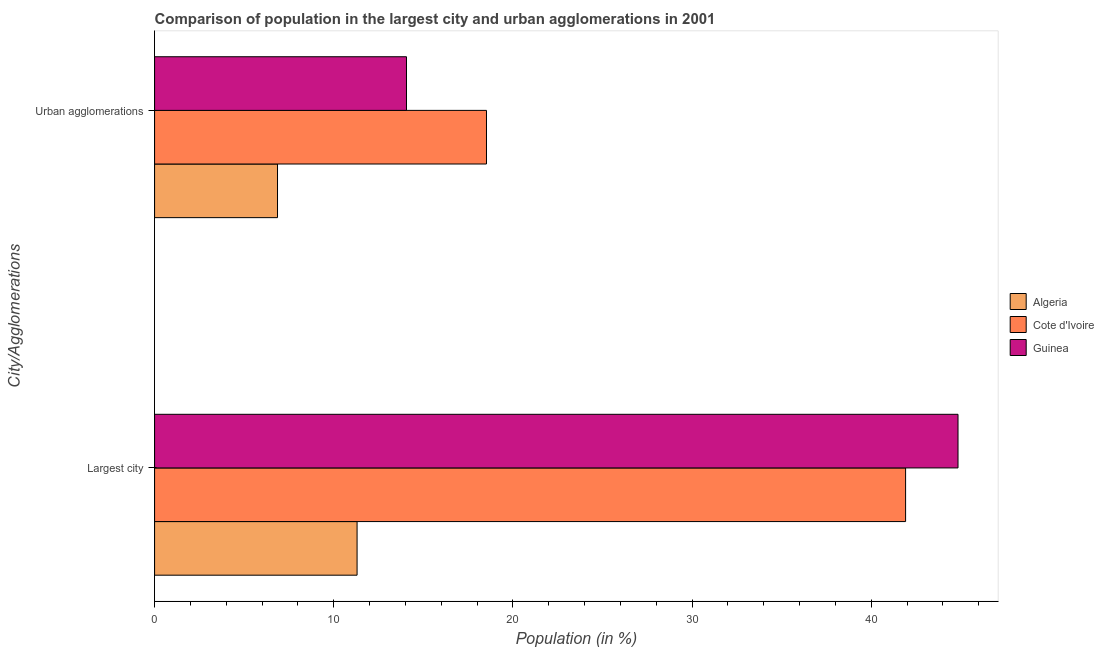Are the number of bars per tick equal to the number of legend labels?
Make the answer very short. Yes. How many bars are there on the 1st tick from the bottom?
Provide a short and direct response. 3. What is the label of the 2nd group of bars from the top?
Your response must be concise. Largest city. What is the population in urban agglomerations in Cote d'Ivoire?
Give a very brief answer. 18.53. Across all countries, what is the maximum population in urban agglomerations?
Make the answer very short. 18.53. Across all countries, what is the minimum population in the largest city?
Your response must be concise. 11.3. In which country was the population in the largest city maximum?
Offer a terse response. Guinea. In which country was the population in the largest city minimum?
Provide a succinct answer. Algeria. What is the total population in the largest city in the graph?
Offer a terse response. 98.07. What is the difference between the population in urban agglomerations in Algeria and that in Cote d'Ivoire?
Make the answer very short. -11.66. What is the difference between the population in the largest city in Algeria and the population in urban agglomerations in Guinea?
Ensure brevity in your answer.  -2.76. What is the average population in the largest city per country?
Ensure brevity in your answer.  32.69. What is the difference between the population in the largest city and population in urban agglomerations in Cote d'Ivoire?
Your response must be concise. 23.39. In how many countries, is the population in urban agglomerations greater than 44 %?
Make the answer very short. 0. What is the ratio of the population in urban agglomerations in Guinea to that in Cote d'Ivoire?
Give a very brief answer. 0.76. Is the population in urban agglomerations in Algeria less than that in Guinea?
Make the answer very short. Yes. In how many countries, is the population in the largest city greater than the average population in the largest city taken over all countries?
Keep it short and to the point. 2. What does the 2nd bar from the top in Largest city represents?
Ensure brevity in your answer.  Cote d'Ivoire. What does the 3rd bar from the bottom in Urban agglomerations represents?
Give a very brief answer. Guinea. How many bars are there?
Give a very brief answer. 6. Are all the bars in the graph horizontal?
Your answer should be compact. Yes. How many countries are there in the graph?
Your answer should be very brief. 3. Are the values on the major ticks of X-axis written in scientific E-notation?
Your answer should be compact. No. Does the graph contain grids?
Give a very brief answer. No. How many legend labels are there?
Ensure brevity in your answer.  3. How are the legend labels stacked?
Provide a succinct answer. Vertical. What is the title of the graph?
Offer a very short reply. Comparison of population in the largest city and urban agglomerations in 2001. What is the label or title of the Y-axis?
Provide a short and direct response. City/Agglomerations. What is the Population (in %) in Algeria in Largest city?
Ensure brevity in your answer.  11.3. What is the Population (in %) of Cote d'Ivoire in Largest city?
Provide a short and direct response. 41.92. What is the Population (in %) of Guinea in Largest city?
Provide a short and direct response. 44.85. What is the Population (in %) in Algeria in Urban agglomerations?
Provide a succinct answer. 6.86. What is the Population (in %) of Cote d'Ivoire in Urban agglomerations?
Provide a short and direct response. 18.53. What is the Population (in %) in Guinea in Urban agglomerations?
Your response must be concise. 14.06. Across all City/Agglomerations, what is the maximum Population (in %) in Algeria?
Offer a very short reply. 11.3. Across all City/Agglomerations, what is the maximum Population (in %) in Cote d'Ivoire?
Offer a terse response. 41.92. Across all City/Agglomerations, what is the maximum Population (in %) of Guinea?
Give a very brief answer. 44.85. Across all City/Agglomerations, what is the minimum Population (in %) in Algeria?
Your response must be concise. 6.86. Across all City/Agglomerations, what is the minimum Population (in %) of Cote d'Ivoire?
Make the answer very short. 18.53. Across all City/Agglomerations, what is the minimum Population (in %) of Guinea?
Offer a terse response. 14.06. What is the total Population (in %) in Algeria in the graph?
Make the answer very short. 18.17. What is the total Population (in %) of Cote d'Ivoire in the graph?
Make the answer very short. 60.45. What is the total Population (in %) in Guinea in the graph?
Offer a terse response. 58.91. What is the difference between the Population (in %) in Algeria in Largest city and that in Urban agglomerations?
Your answer should be compact. 4.44. What is the difference between the Population (in %) in Cote d'Ivoire in Largest city and that in Urban agglomerations?
Offer a terse response. 23.39. What is the difference between the Population (in %) in Guinea in Largest city and that in Urban agglomerations?
Offer a terse response. 30.79. What is the difference between the Population (in %) in Algeria in Largest city and the Population (in %) in Cote d'Ivoire in Urban agglomerations?
Keep it short and to the point. -7.22. What is the difference between the Population (in %) in Algeria in Largest city and the Population (in %) in Guinea in Urban agglomerations?
Provide a short and direct response. -2.76. What is the difference between the Population (in %) of Cote d'Ivoire in Largest city and the Population (in %) of Guinea in Urban agglomerations?
Provide a succinct answer. 27.86. What is the average Population (in %) in Algeria per City/Agglomerations?
Your response must be concise. 9.08. What is the average Population (in %) of Cote d'Ivoire per City/Agglomerations?
Provide a short and direct response. 30.22. What is the average Population (in %) in Guinea per City/Agglomerations?
Provide a succinct answer. 29.45. What is the difference between the Population (in %) of Algeria and Population (in %) of Cote d'Ivoire in Largest city?
Make the answer very short. -30.62. What is the difference between the Population (in %) in Algeria and Population (in %) in Guinea in Largest city?
Ensure brevity in your answer.  -33.54. What is the difference between the Population (in %) of Cote d'Ivoire and Population (in %) of Guinea in Largest city?
Provide a succinct answer. -2.93. What is the difference between the Population (in %) in Algeria and Population (in %) in Cote d'Ivoire in Urban agglomerations?
Offer a very short reply. -11.66. What is the difference between the Population (in %) in Algeria and Population (in %) in Guinea in Urban agglomerations?
Give a very brief answer. -7.2. What is the difference between the Population (in %) of Cote d'Ivoire and Population (in %) of Guinea in Urban agglomerations?
Your response must be concise. 4.47. What is the ratio of the Population (in %) in Algeria in Largest city to that in Urban agglomerations?
Provide a short and direct response. 1.65. What is the ratio of the Population (in %) in Cote d'Ivoire in Largest city to that in Urban agglomerations?
Provide a succinct answer. 2.26. What is the ratio of the Population (in %) in Guinea in Largest city to that in Urban agglomerations?
Keep it short and to the point. 3.19. What is the difference between the highest and the second highest Population (in %) in Algeria?
Your answer should be very brief. 4.44. What is the difference between the highest and the second highest Population (in %) in Cote d'Ivoire?
Provide a succinct answer. 23.39. What is the difference between the highest and the second highest Population (in %) in Guinea?
Your answer should be compact. 30.79. What is the difference between the highest and the lowest Population (in %) of Algeria?
Your answer should be very brief. 4.44. What is the difference between the highest and the lowest Population (in %) of Cote d'Ivoire?
Provide a short and direct response. 23.39. What is the difference between the highest and the lowest Population (in %) in Guinea?
Your answer should be very brief. 30.79. 